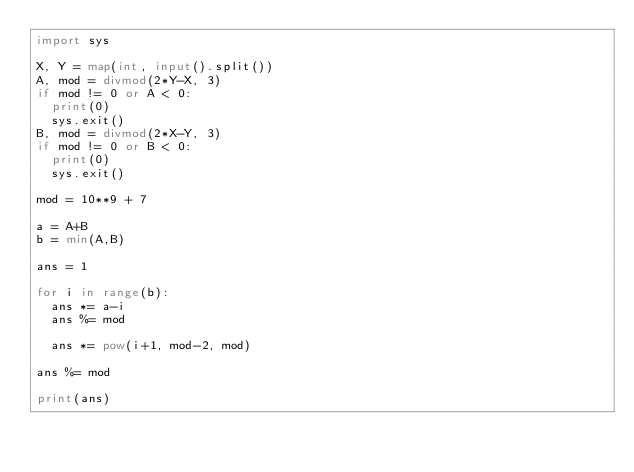<code> <loc_0><loc_0><loc_500><loc_500><_Python_>import sys

X, Y = map(int, input().split())
A, mod = divmod(2*Y-X, 3)
if mod != 0 or A < 0:
	print(0)
	sys.exit()
B, mod = divmod(2*X-Y, 3)
if mod != 0 or B < 0:
	print(0)
	sys.exit()

mod = 10**9 + 7

a = A+B
b = min(A,B)

ans = 1

for i in range(b):
	ans *= a-i
	ans %= mod

	ans *= pow(i+1, mod-2, mod)

ans %= mod

print(ans)</code> 